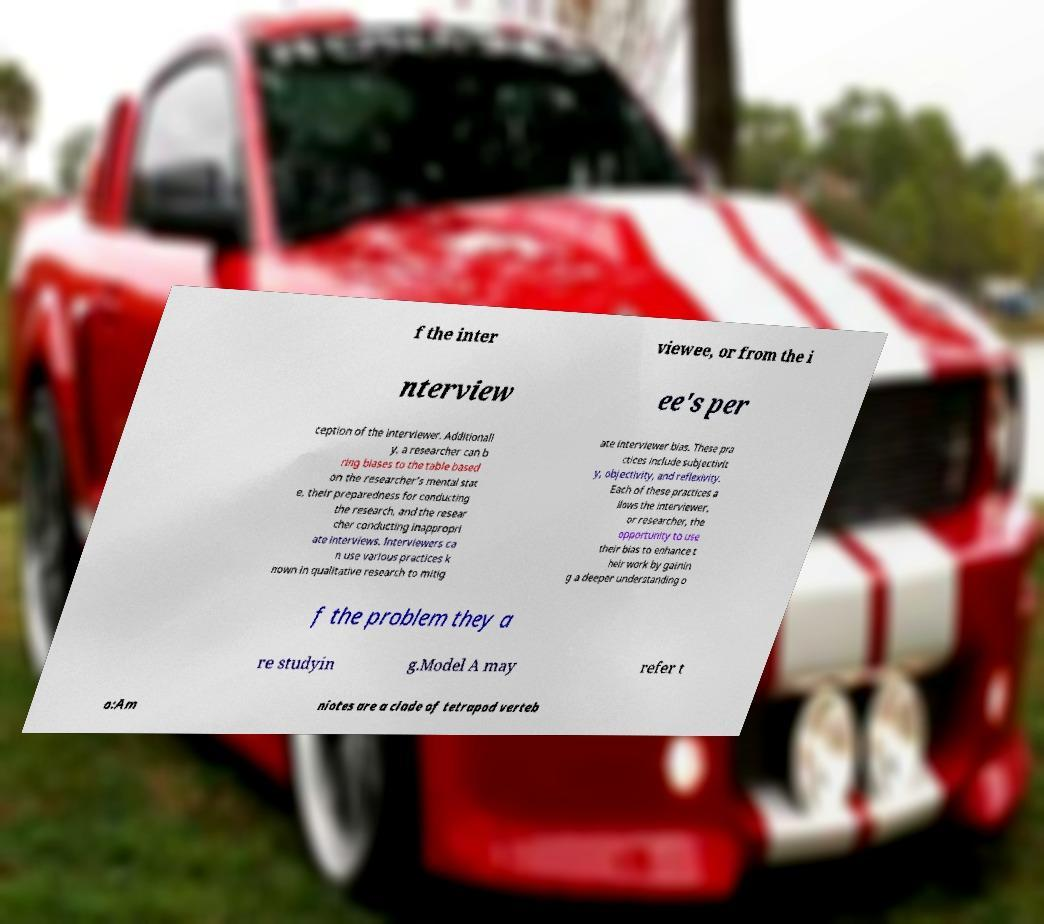Can you read and provide the text displayed in the image?This photo seems to have some interesting text. Can you extract and type it out for me? f the inter viewee, or from the i nterview ee's per ception of the interviewer. Additionall y, a researcher can b ring biases to the table based on the researcher’s mental stat e, their preparedness for conducting the research, and the resear cher conducting inappropri ate interviews. Interviewers ca n use various practices k nown in qualitative research to mitig ate interviewer bias. These pra ctices include subjectivit y, objectivity, and reflexivity. Each of these practices a llows the interviewer, or researcher, the opportunity to use their bias to enhance t heir work by gainin g a deeper understanding o f the problem they a re studyin g.Model A may refer t o:Am niotes are a clade of tetrapod verteb 